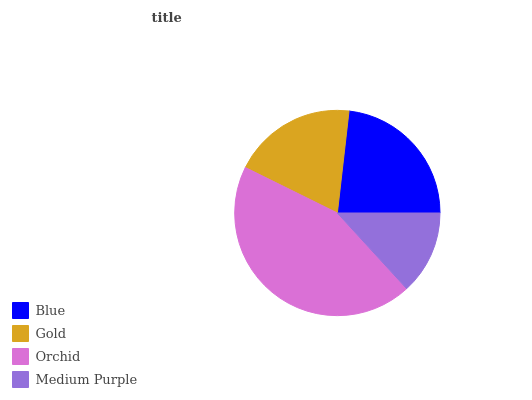Is Medium Purple the minimum?
Answer yes or no. Yes. Is Orchid the maximum?
Answer yes or no. Yes. Is Gold the minimum?
Answer yes or no. No. Is Gold the maximum?
Answer yes or no. No. Is Blue greater than Gold?
Answer yes or no. Yes. Is Gold less than Blue?
Answer yes or no. Yes. Is Gold greater than Blue?
Answer yes or no. No. Is Blue less than Gold?
Answer yes or no. No. Is Blue the high median?
Answer yes or no. Yes. Is Gold the low median?
Answer yes or no. Yes. Is Medium Purple the high median?
Answer yes or no. No. Is Blue the low median?
Answer yes or no. No. 